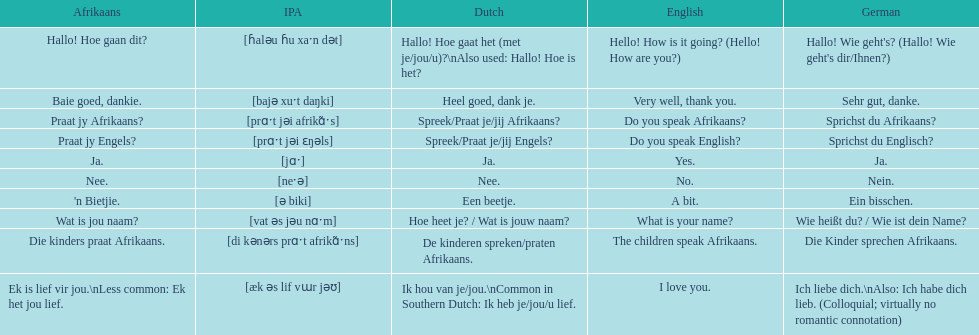What is the way to say 'do you speak afrikaans?' in afrikaans? Praat jy Afrikaans?. 